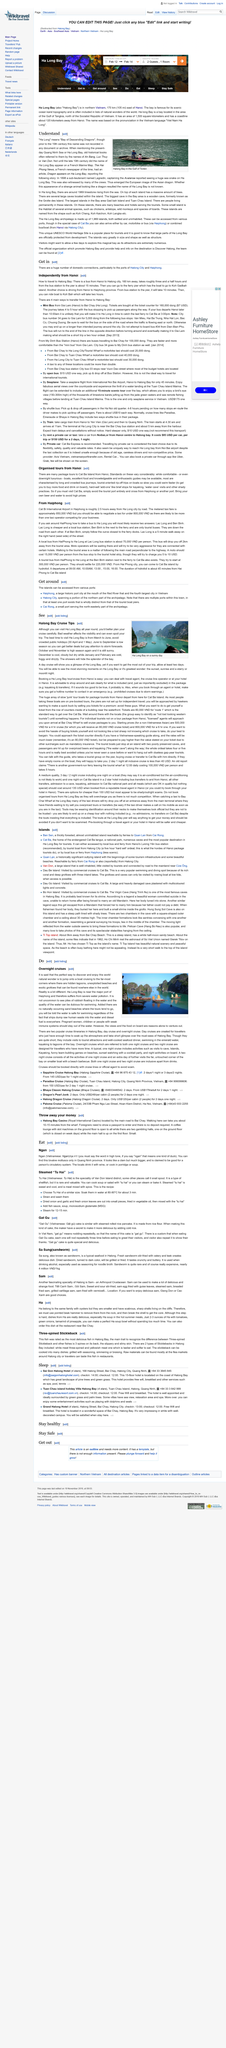Indicate a few pertinent items in this graphic. The image depicts Halong Bay in the Gulf of Tonkin, which is also known to be pictured. Ha Long" is a Vietnamese term that translates to "Bay of Descending Dragons. The name "Ha Long Bay" appeared on a French Marine Map in the 19th century. 